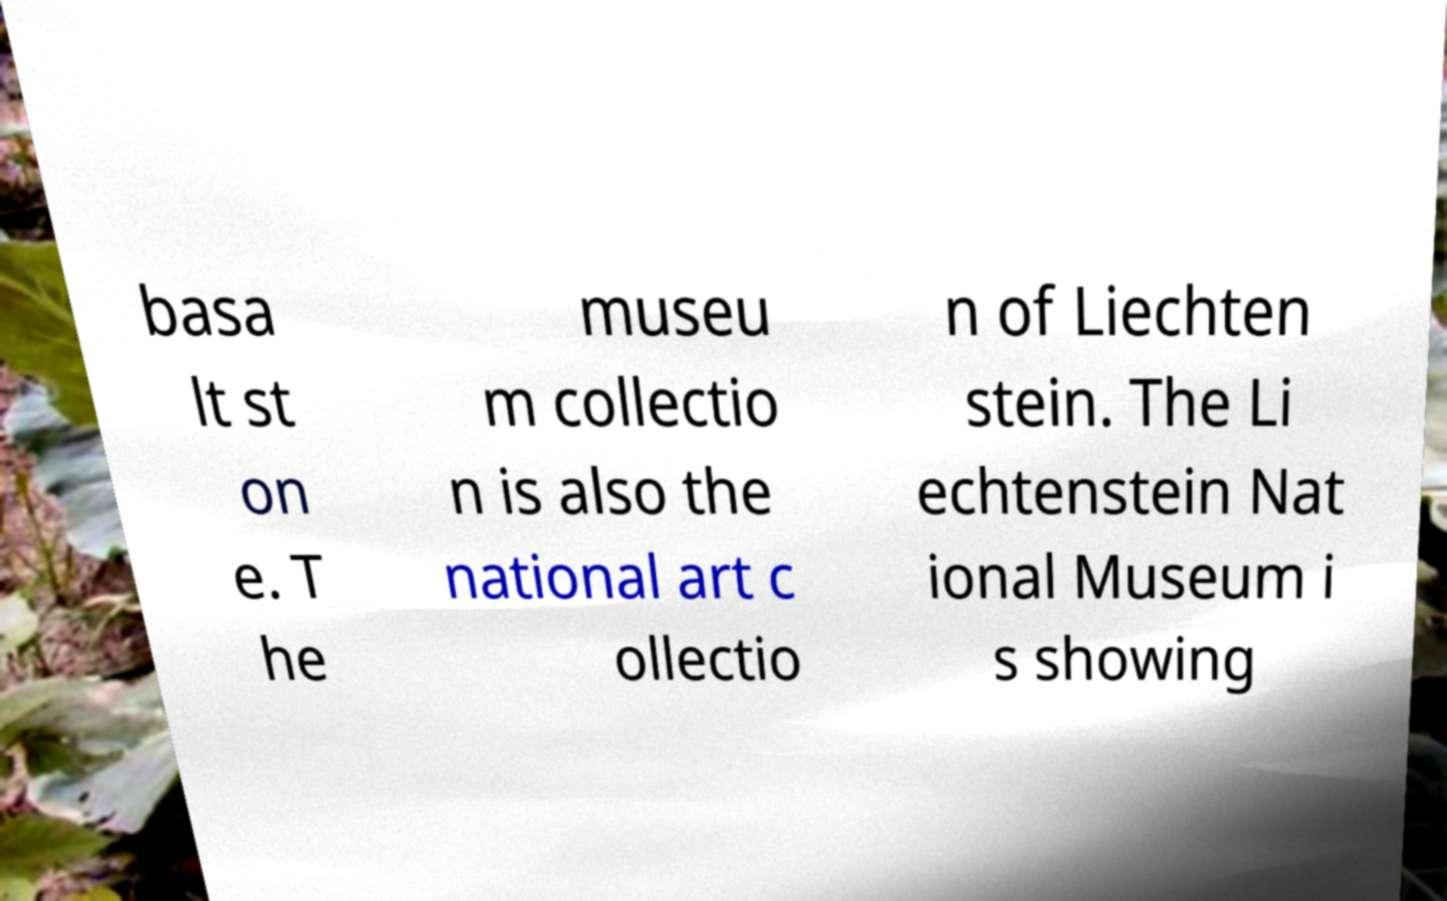I need the written content from this picture converted into text. Can you do that? basa lt st on e. T he museu m collectio n is also the national art c ollectio n of Liechten stein. The Li echtenstein Nat ional Museum i s showing 